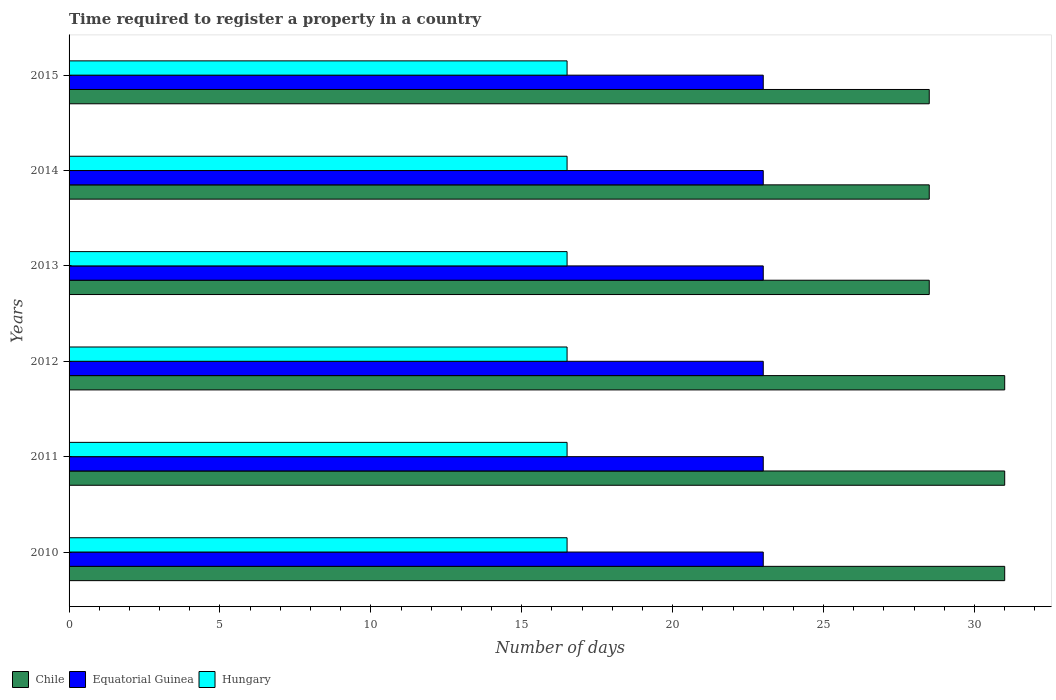How many groups of bars are there?
Offer a very short reply. 6. Are the number of bars on each tick of the Y-axis equal?
Keep it short and to the point. Yes. How many bars are there on the 3rd tick from the top?
Offer a terse response. 3. How many bars are there on the 2nd tick from the bottom?
Make the answer very short. 3. What is the number of days required to register a property in Hungary in 2014?
Provide a short and direct response. 16.5. Across all years, what is the maximum number of days required to register a property in Hungary?
Provide a succinct answer. 16.5. In which year was the number of days required to register a property in Hungary maximum?
Your answer should be compact. 2010. In which year was the number of days required to register a property in Equatorial Guinea minimum?
Ensure brevity in your answer.  2010. What is the total number of days required to register a property in Equatorial Guinea in the graph?
Keep it short and to the point. 138. What is the average number of days required to register a property in Chile per year?
Provide a short and direct response. 29.75. In the year 2011, what is the difference between the number of days required to register a property in Hungary and number of days required to register a property in Chile?
Offer a terse response. -14.5. Is the difference between the number of days required to register a property in Hungary in 2010 and 2011 greater than the difference between the number of days required to register a property in Chile in 2010 and 2011?
Give a very brief answer. No. Is the sum of the number of days required to register a property in Equatorial Guinea in 2012 and 2015 greater than the maximum number of days required to register a property in Chile across all years?
Your answer should be very brief. Yes. What does the 2nd bar from the top in 2013 represents?
Offer a very short reply. Equatorial Guinea. What does the 3rd bar from the bottom in 2012 represents?
Provide a succinct answer. Hungary. How many bars are there?
Make the answer very short. 18. Are all the bars in the graph horizontal?
Your response must be concise. Yes. How many years are there in the graph?
Provide a succinct answer. 6. Does the graph contain grids?
Offer a terse response. No. How many legend labels are there?
Offer a very short reply. 3. What is the title of the graph?
Offer a terse response. Time required to register a property in a country. What is the label or title of the X-axis?
Offer a very short reply. Number of days. What is the Number of days in Chile in 2010?
Offer a very short reply. 31. What is the Number of days in Hungary in 2010?
Make the answer very short. 16.5. What is the Number of days of Hungary in 2011?
Offer a very short reply. 16.5. What is the Number of days of Chile in 2014?
Give a very brief answer. 28.5. What is the Number of days in Equatorial Guinea in 2014?
Ensure brevity in your answer.  23. What is the Number of days of Hungary in 2014?
Provide a succinct answer. 16.5. What is the Number of days in Equatorial Guinea in 2015?
Offer a very short reply. 23. Across all years, what is the minimum Number of days of Equatorial Guinea?
Provide a succinct answer. 23. Across all years, what is the minimum Number of days of Hungary?
Your response must be concise. 16.5. What is the total Number of days in Chile in the graph?
Offer a very short reply. 178.5. What is the total Number of days of Equatorial Guinea in the graph?
Offer a terse response. 138. What is the total Number of days of Hungary in the graph?
Your answer should be very brief. 99. What is the difference between the Number of days of Hungary in 2010 and that in 2011?
Ensure brevity in your answer.  0. What is the difference between the Number of days of Equatorial Guinea in 2010 and that in 2012?
Your answer should be compact. 0. What is the difference between the Number of days in Chile in 2010 and that in 2013?
Make the answer very short. 2.5. What is the difference between the Number of days of Equatorial Guinea in 2010 and that in 2013?
Give a very brief answer. 0. What is the difference between the Number of days of Hungary in 2010 and that in 2013?
Give a very brief answer. 0. What is the difference between the Number of days in Equatorial Guinea in 2010 and that in 2014?
Provide a succinct answer. 0. What is the difference between the Number of days of Hungary in 2011 and that in 2012?
Your answer should be very brief. 0. What is the difference between the Number of days of Chile in 2011 and that in 2013?
Give a very brief answer. 2.5. What is the difference between the Number of days in Hungary in 2011 and that in 2013?
Ensure brevity in your answer.  0. What is the difference between the Number of days of Equatorial Guinea in 2011 and that in 2014?
Give a very brief answer. 0. What is the difference between the Number of days in Chile in 2011 and that in 2015?
Offer a very short reply. 2.5. What is the difference between the Number of days of Hungary in 2011 and that in 2015?
Your response must be concise. 0. What is the difference between the Number of days of Equatorial Guinea in 2012 and that in 2013?
Keep it short and to the point. 0. What is the difference between the Number of days of Chile in 2012 and that in 2014?
Provide a succinct answer. 2.5. What is the difference between the Number of days in Equatorial Guinea in 2012 and that in 2014?
Make the answer very short. 0. What is the difference between the Number of days of Hungary in 2012 and that in 2014?
Provide a short and direct response. 0. What is the difference between the Number of days in Chile in 2012 and that in 2015?
Keep it short and to the point. 2.5. What is the difference between the Number of days in Equatorial Guinea in 2012 and that in 2015?
Your answer should be very brief. 0. What is the difference between the Number of days in Hungary in 2012 and that in 2015?
Offer a very short reply. 0. What is the difference between the Number of days of Chile in 2013 and that in 2015?
Offer a terse response. 0. What is the difference between the Number of days in Chile in 2014 and that in 2015?
Make the answer very short. 0. What is the difference between the Number of days of Equatorial Guinea in 2014 and that in 2015?
Provide a short and direct response. 0. What is the difference between the Number of days in Equatorial Guinea in 2010 and the Number of days in Hungary in 2011?
Make the answer very short. 6.5. What is the difference between the Number of days of Chile in 2010 and the Number of days of Equatorial Guinea in 2012?
Offer a terse response. 8. What is the difference between the Number of days in Chile in 2010 and the Number of days in Hungary in 2012?
Provide a short and direct response. 14.5. What is the difference between the Number of days of Equatorial Guinea in 2010 and the Number of days of Hungary in 2012?
Your answer should be compact. 6.5. What is the difference between the Number of days in Chile in 2010 and the Number of days in Hungary in 2013?
Your answer should be compact. 14.5. What is the difference between the Number of days in Chile in 2010 and the Number of days in Equatorial Guinea in 2014?
Provide a succinct answer. 8. What is the difference between the Number of days in Chile in 2010 and the Number of days in Equatorial Guinea in 2015?
Make the answer very short. 8. What is the difference between the Number of days of Chile in 2010 and the Number of days of Hungary in 2015?
Offer a very short reply. 14.5. What is the difference between the Number of days in Chile in 2011 and the Number of days in Hungary in 2012?
Provide a succinct answer. 14.5. What is the difference between the Number of days in Equatorial Guinea in 2011 and the Number of days in Hungary in 2012?
Offer a very short reply. 6.5. What is the difference between the Number of days in Equatorial Guinea in 2011 and the Number of days in Hungary in 2014?
Make the answer very short. 6.5. What is the difference between the Number of days in Chile in 2011 and the Number of days in Equatorial Guinea in 2015?
Provide a succinct answer. 8. What is the difference between the Number of days of Equatorial Guinea in 2012 and the Number of days of Hungary in 2013?
Your answer should be very brief. 6.5. What is the difference between the Number of days in Chile in 2012 and the Number of days in Hungary in 2015?
Your answer should be very brief. 14.5. What is the difference between the Number of days of Equatorial Guinea in 2012 and the Number of days of Hungary in 2015?
Your response must be concise. 6.5. What is the difference between the Number of days of Equatorial Guinea in 2013 and the Number of days of Hungary in 2014?
Give a very brief answer. 6.5. What is the difference between the Number of days in Chile in 2013 and the Number of days in Equatorial Guinea in 2015?
Provide a short and direct response. 5.5. What is the difference between the Number of days of Chile in 2013 and the Number of days of Hungary in 2015?
Provide a succinct answer. 12. What is the difference between the Number of days of Chile in 2014 and the Number of days of Equatorial Guinea in 2015?
Your answer should be compact. 5.5. What is the difference between the Number of days of Equatorial Guinea in 2014 and the Number of days of Hungary in 2015?
Keep it short and to the point. 6.5. What is the average Number of days of Chile per year?
Provide a short and direct response. 29.75. In the year 2010, what is the difference between the Number of days of Equatorial Guinea and Number of days of Hungary?
Your answer should be compact. 6.5. In the year 2011, what is the difference between the Number of days in Chile and Number of days in Equatorial Guinea?
Your answer should be very brief. 8. In the year 2011, what is the difference between the Number of days in Chile and Number of days in Hungary?
Provide a succinct answer. 14.5. In the year 2011, what is the difference between the Number of days of Equatorial Guinea and Number of days of Hungary?
Provide a short and direct response. 6.5. In the year 2012, what is the difference between the Number of days in Chile and Number of days in Equatorial Guinea?
Your response must be concise. 8. In the year 2012, what is the difference between the Number of days in Equatorial Guinea and Number of days in Hungary?
Your answer should be compact. 6.5. In the year 2013, what is the difference between the Number of days of Chile and Number of days of Hungary?
Your answer should be very brief. 12. In the year 2014, what is the difference between the Number of days of Chile and Number of days of Hungary?
Make the answer very short. 12. In the year 2015, what is the difference between the Number of days in Chile and Number of days in Equatorial Guinea?
Provide a short and direct response. 5.5. In the year 2015, what is the difference between the Number of days in Chile and Number of days in Hungary?
Give a very brief answer. 12. In the year 2015, what is the difference between the Number of days in Equatorial Guinea and Number of days in Hungary?
Your answer should be compact. 6.5. What is the ratio of the Number of days of Chile in 2010 to that in 2011?
Ensure brevity in your answer.  1. What is the ratio of the Number of days of Equatorial Guinea in 2010 to that in 2011?
Your response must be concise. 1. What is the ratio of the Number of days of Chile in 2010 to that in 2012?
Provide a succinct answer. 1. What is the ratio of the Number of days in Hungary in 2010 to that in 2012?
Offer a very short reply. 1. What is the ratio of the Number of days in Chile in 2010 to that in 2013?
Offer a terse response. 1.09. What is the ratio of the Number of days of Hungary in 2010 to that in 2013?
Your response must be concise. 1. What is the ratio of the Number of days in Chile in 2010 to that in 2014?
Provide a succinct answer. 1.09. What is the ratio of the Number of days of Equatorial Guinea in 2010 to that in 2014?
Make the answer very short. 1. What is the ratio of the Number of days of Hungary in 2010 to that in 2014?
Your answer should be compact. 1. What is the ratio of the Number of days of Chile in 2010 to that in 2015?
Keep it short and to the point. 1.09. What is the ratio of the Number of days in Equatorial Guinea in 2010 to that in 2015?
Your response must be concise. 1. What is the ratio of the Number of days of Chile in 2011 to that in 2012?
Offer a terse response. 1. What is the ratio of the Number of days of Equatorial Guinea in 2011 to that in 2012?
Ensure brevity in your answer.  1. What is the ratio of the Number of days in Hungary in 2011 to that in 2012?
Keep it short and to the point. 1. What is the ratio of the Number of days in Chile in 2011 to that in 2013?
Provide a short and direct response. 1.09. What is the ratio of the Number of days in Hungary in 2011 to that in 2013?
Provide a short and direct response. 1. What is the ratio of the Number of days of Chile in 2011 to that in 2014?
Provide a short and direct response. 1.09. What is the ratio of the Number of days in Chile in 2011 to that in 2015?
Ensure brevity in your answer.  1.09. What is the ratio of the Number of days of Equatorial Guinea in 2011 to that in 2015?
Your answer should be very brief. 1. What is the ratio of the Number of days of Chile in 2012 to that in 2013?
Offer a terse response. 1.09. What is the ratio of the Number of days of Hungary in 2012 to that in 2013?
Your answer should be very brief. 1. What is the ratio of the Number of days of Chile in 2012 to that in 2014?
Provide a short and direct response. 1.09. What is the ratio of the Number of days in Chile in 2012 to that in 2015?
Offer a very short reply. 1.09. What is the ratio of the Number of days in Equatorial Guinea in 2012 to that in 2015?
Provide a succinct answer. 1. What is the ratio of the Number of days of Hungary in 2012 to that in 2015?
Give a very brief answer. 1. What is the ratio of the Number of days of Chile in 2013 to that in 2014?
Give a very brief answer. 1. What is the ratio of the Number of days of Hungary in 2013 to that in 2015?
Make the answer very short. 1. What is the ratio of the Number of days in Chile in 2014 to that in 2015?
Your answer should be very brief. 1. What is the ratio of the Number of days in Equatorial Guinea in 2014 to that in 2015?
Give a very brief answer. 1. What is the ratio of the Number of days of Hungary in 2014 to that in 2015?
Offer a very short reply. 1. 